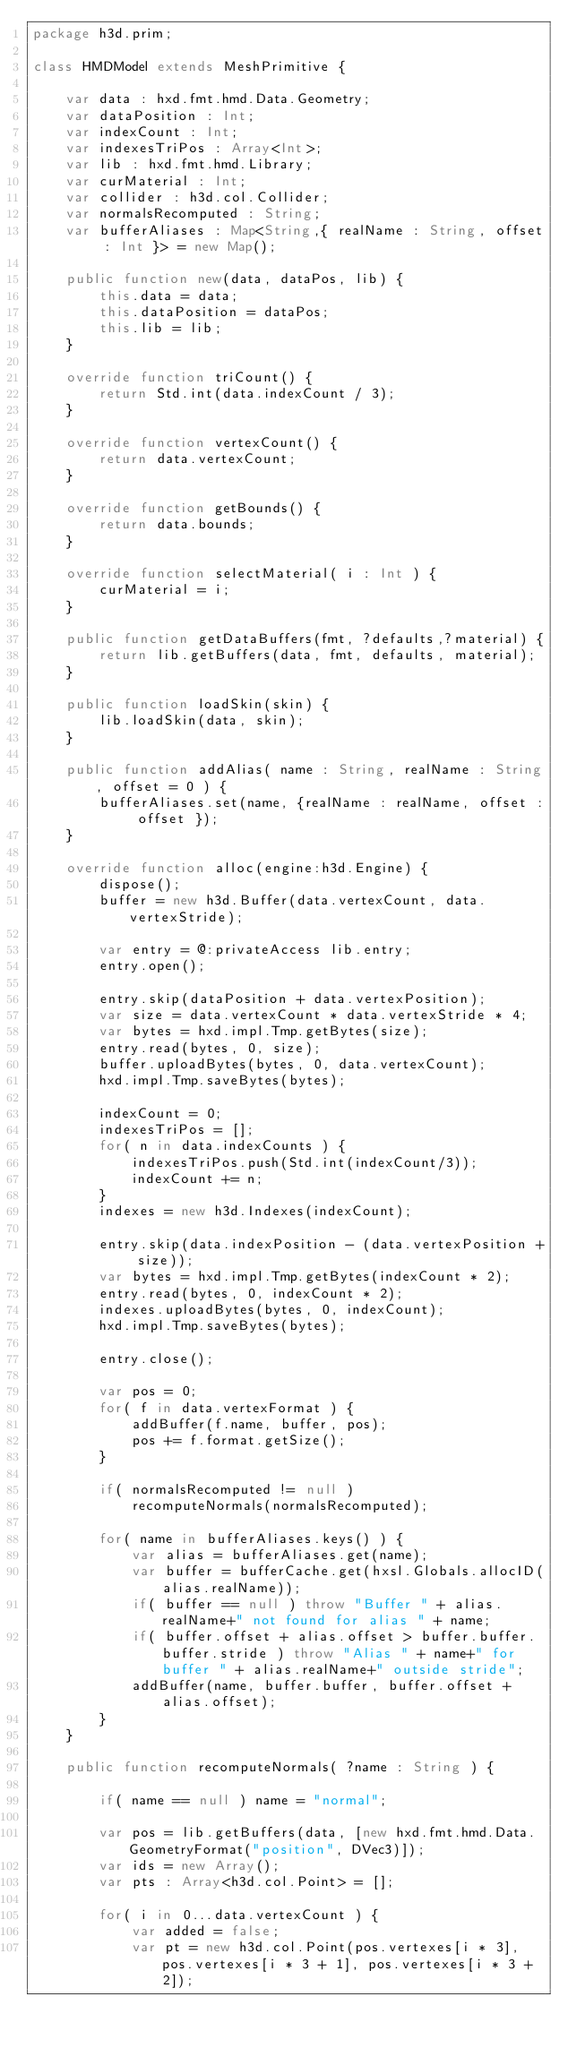Convert code to text. <code><loc_0><loc_0><loc_500><loc_500><_Haxe_>package h3d.prim;

class HMDModel extends MeshPrimitive {

	var data : hxd.fmt.hmd.Data.Geometry;
	var dataPosition : Int;
	var indexCount : Int;
	var indexesTriPos : Array<Int>;
	var lib : hxd.fmt.hmd.Library;
	var curMaterial : Int;
	var collider : h3d.col.Collider;
	var normalsRecomputed : String;
	var bufferAliases : Map<String,{ realName : String, offset : Int }> = new Map();

	public function new(data, dataPos, lib) {
		this.data = data;
		this.dataPosition = dataPos;
		this.lib = lib;
	}

	override function triCount() {
		return Std.int(data.indexCount / 3);
	}

	override function vertexCount() {
		return data.vertexCount;
	}

	override function getBounds() {
		return data.bounds;
	}

	override function selectMaterial( i : Int ) {
		curMaterial = i;
	}

	public function getDataBuffers(fmt, ?defaults,?material) {
		return lib.getBuffers(data, fmt, defaults, material);
	}

	public function loadSkin(skin) {
		lib.loadSkin(data, skin);
	}

	public function addAlias( name : String, realName : String, offset = 0 ) {
		bufferAliases.set(name, {realName : realName, offset : offset });
	}

	override function alloc(engine:h3d.Engine) {
		dispose();
		buffer = new h3d.Buffer(data.vertexCount, data.vertexStride);

		var entry = @:privateAccess lib.entry;
		entry.open();

		entry.skip(dataPosition + data.vertexPosition);
		var size = data.vertexCount * data.vertexStride * 4;
		var bytes = hxd.impl.Tmp.getBytes(size);
		entry.read(bytes, 0, size);
		buffer.uploadBytes(bytes, 0, data.vertexCount);
		hxd.impl.Tmp.saveBytes(bytes);

		indexCount = 0;
		indexesTriPos = [];
		for( n in data.indexCounts ) {
			indexesTriPos.push(Std.int(indexCount/3));
			indexCount += n;
		}
		indexes = new h3d.Indexes(indexCount);

		entry.skip(data.indexPosition - (data.vertexPosition + size));
		var bytes = hxd.impl.Tmp.getBytes(indexCount * 2);
		entry.read(bytes, 0, indexCount * 2);
		indexes.uploadBytes(bytes, 0, indexCount);
		hxd.impl.Tmp.saveBytes(bytes);

		entry.close();

		var pos = 0;
		for( f in data.vertexFormat ) {
			addBuffer(f.name, buffer, pos);
			pos += f.format.getSize();
		}

		if( normalsRecomputed != null )
			recomputeNormals(normalsRecomputed);

		for( name in bufferAliases.keys() ) {
			var alias = bufferAliases.get(name);
			var buffer = bufferCache.get(hxsl.Globals.allocID(alias.realName));
			if( buffer == null ) throw "Buffer " + alias.realName+" not found for alias " + name;
			if( buffer.offset + alias.offset > buffer.buffer.buffer.stride ) throw "Alias " + name+" for buffer " + alias.realName+" outside stride";
			addBuffer(name, buffer.buffer, buffer.offset + alias.offset);
		}
	}

	public function recomputeNormals( ?name : String ) {

		if( name == null ) name = "normal";

		var pos = lib.getBuffers(data, [new hxd.fmt.hmd.Data.GeometryFormat("position", DVec3)]);
		var ids = new Array();
		var pts : Array<h3d.col.Point> = [];

		for( i in 0...data.vertexCount ) {
			var added = false;
			var pt = new h3d.col.Point(pos.vertexes[i * 3], pos.vertexes[i * 3 + 1], pos.vertexes[i * 3 + 2]);</code> 